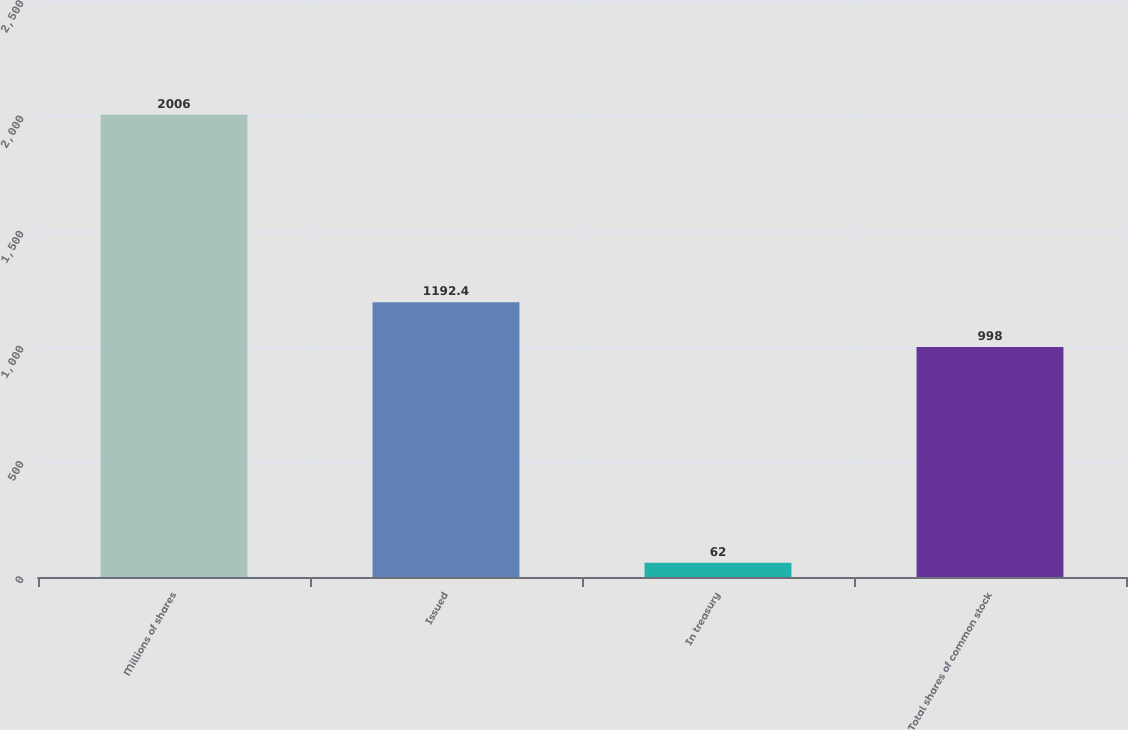Convert chart to OTSL. <chart><loc_0><loc_0><loc_500><loc_500><bar_chart><fcel>Millions of shares<fcel>Issued<fcel>In treasury<fcel>Total shares of common stock<nl><fcel>2006<fcel>1192.4<fcel>62<fcel>998<nl></chart> 